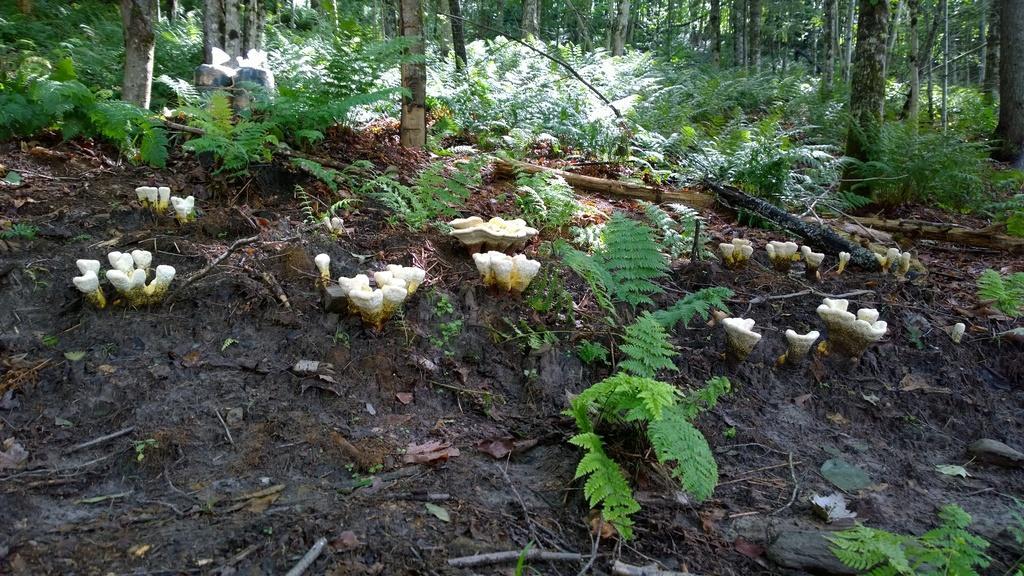Can you describe this image briefly? In this image I can see a forest , in the forest I can see mushrooms visible on the land in the middle and I can see trees. 